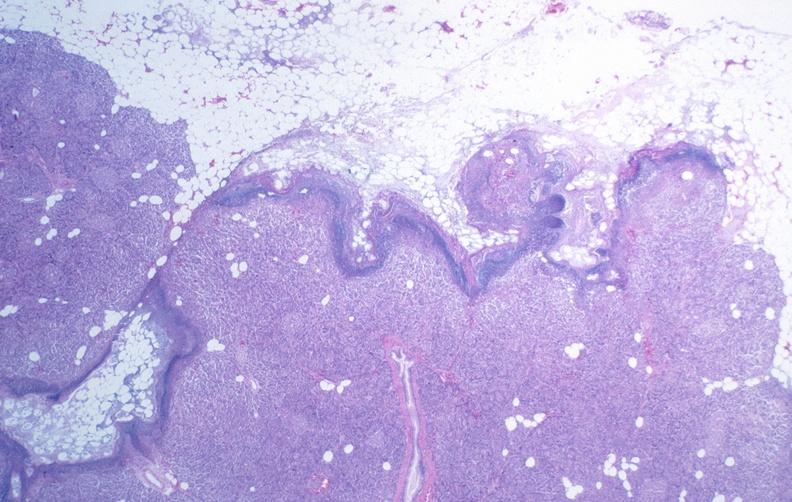what does this image show?
Answer the question using a single word or phrase. Pancreatic fat necrosis 